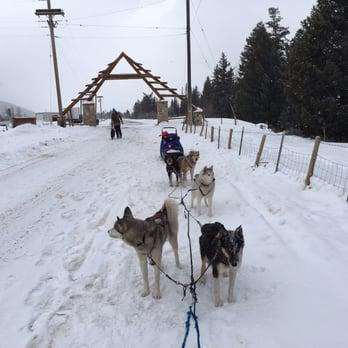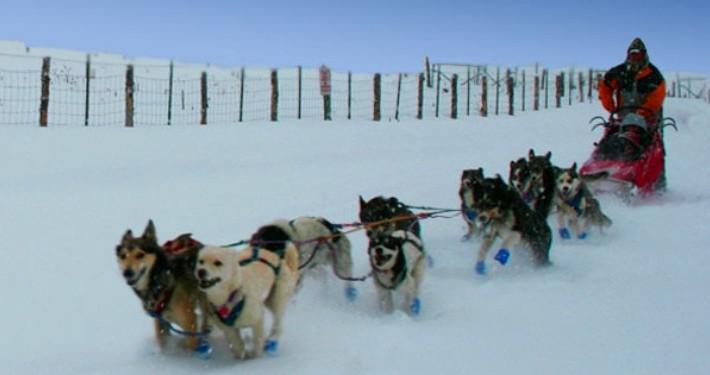The first image is the image on the left, the second image is the image on the right. Considering the images on both sides, is "The dog sled team on the right heads diagonally to the left, and the dog team on the left heads toward the camera." valid? Answer yes or no. Yes. The first image is the image on the left, the second image is the image on the right. Assess this claim about the two images: "The dogs in the left image are standing still, and the dogs in the right image are running.". Correct or not? Answer yes or no. Yes. 